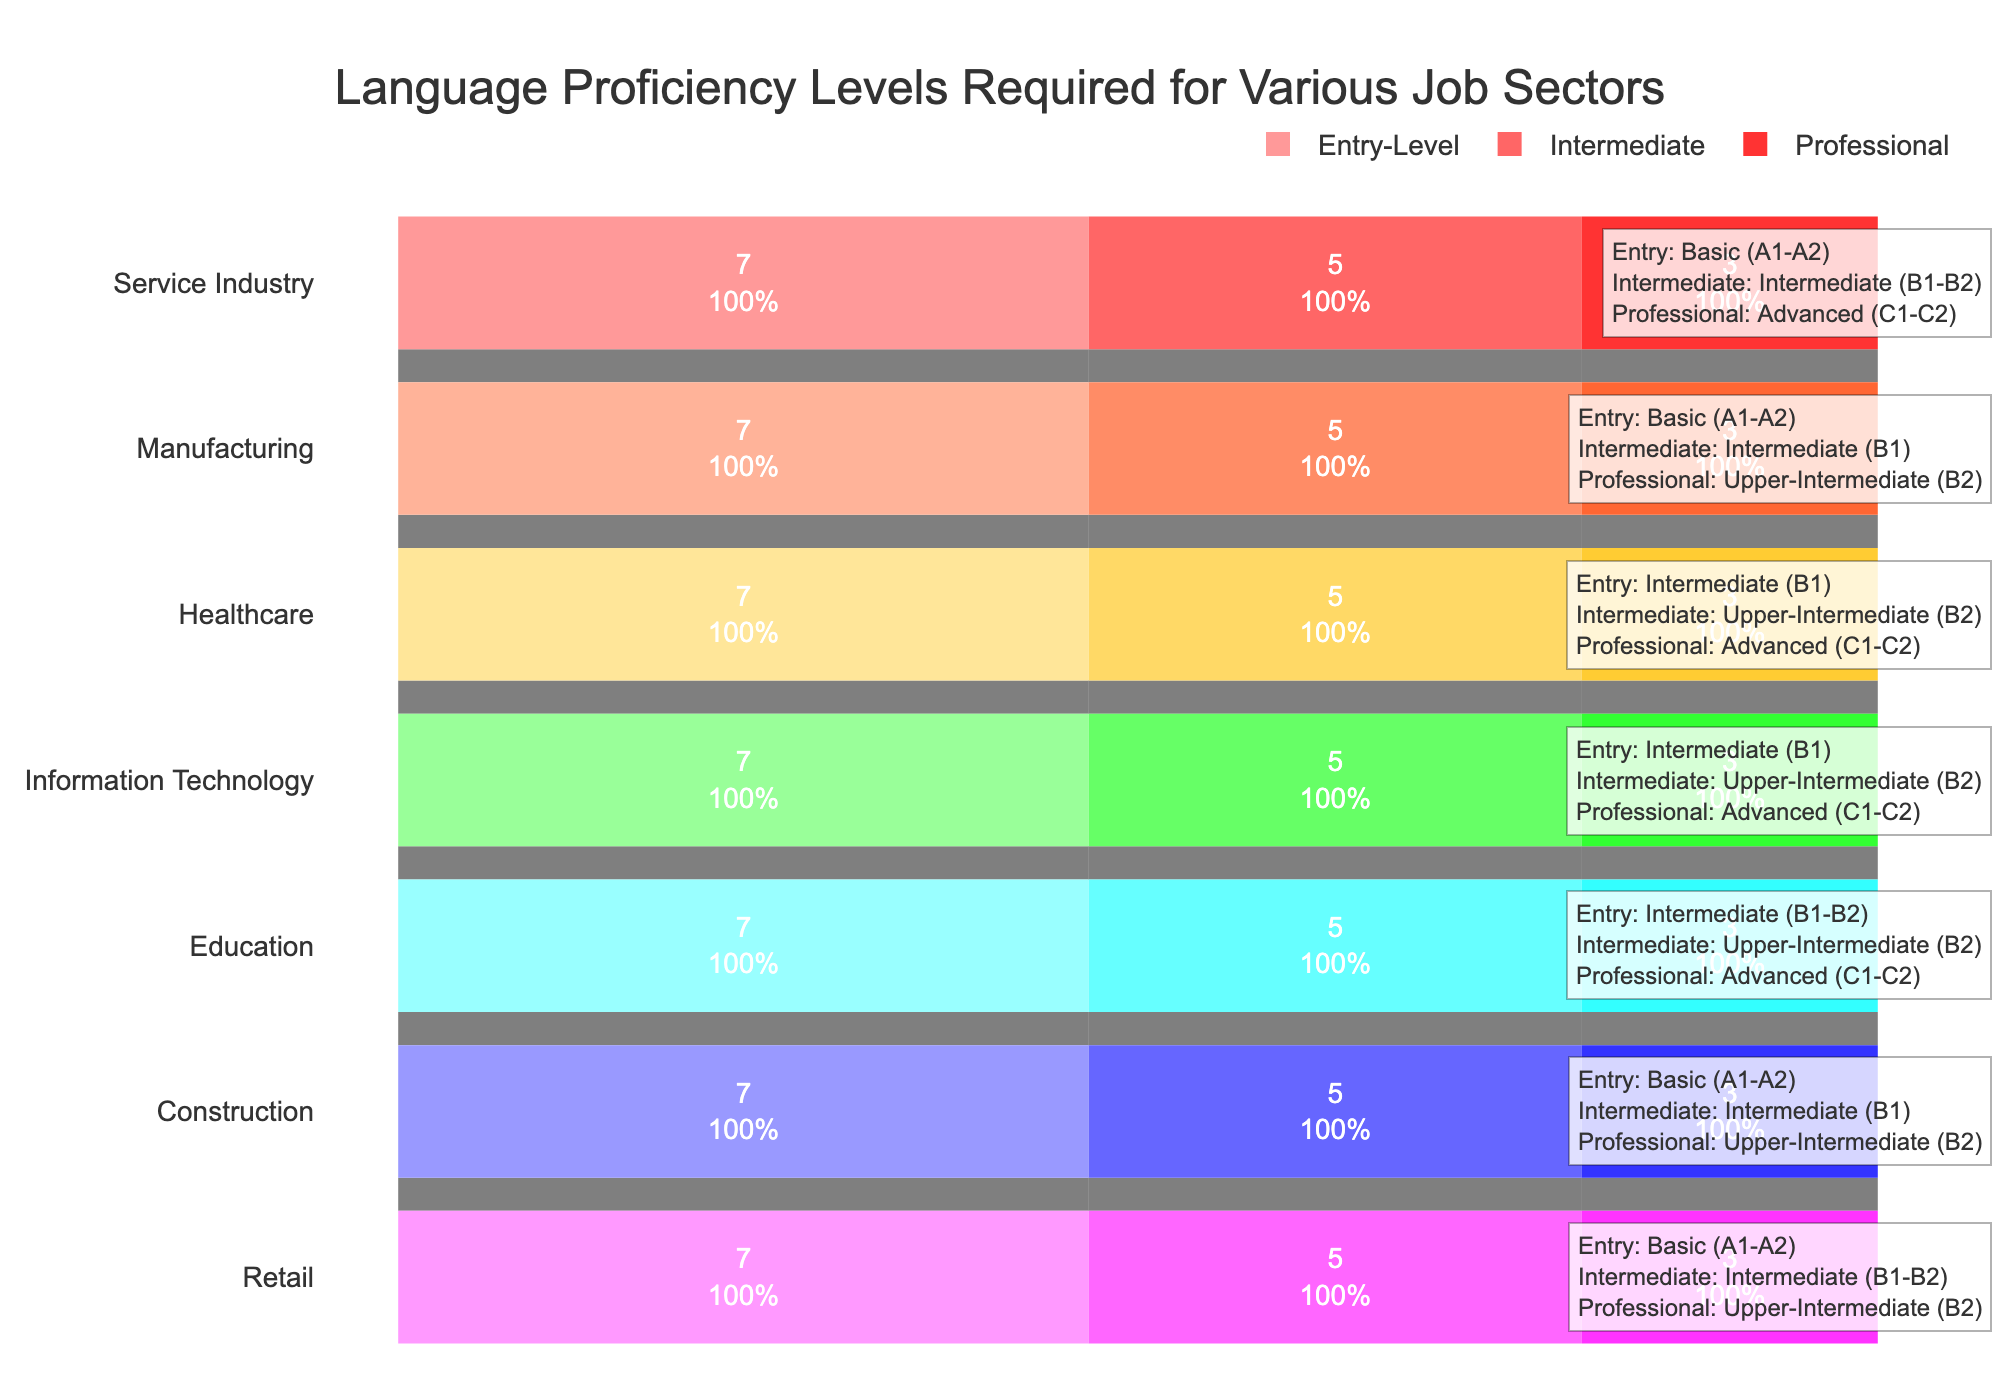What is the title of the funnel chart? The title is typically located at the top of the figure and is meant to give a succinct summary of the chart's purpose or content. In this case, the title directly states what the chart is depicting.
Answer: Language Proficiency Levels Required for Various Job Sectors Which job sector requires at least Intermediate (B1-B2) proficiency for entry-level roles? To answer, look for job sectors in the funnel chart that have "Intermediate" listed for the Entry-Level stage.
Answer: Education What language proficiency level is generally required for entry-level roles in the Service Industry? To answer, refer to the portion of the funnel chart that corresponds to the Service Industry and check the entry-level section.
Answer: Basic (A1-A2) How many job sectors are listed in the funnel chart? Count the number of unique job sectors listed on the y-axis of the funnel chart.
Answer: 7 Which job sectors require Advanced (C1-C2) proficiency for professional roles? Look at the professional proficiency segment (top-most part of each funnel) and identify those that specifically list Advanced (C1-C2) proficiency.
Answer: Service Industry, Healthcare, Information Technology, Education Compare the language proficiency required for intermediate roles in Retail and Healthcare. First, identify the language proficiency levels for intermediate roles in both Retail and Healthcare; then describe or compare the levels. Retail requires (B1-B2) while Healthcare requires (B2).
Answer: Retail: Intermediate (B1-B2), Healthcare: Upper-Intermediate (B2) What is the overall trend in language proficiency levels for job sectors as roles progress from entry-level to professional? Examine the progression of language requirements from entry-level to professional roles across all job sectors. There is a general requirement for higher proficiency levels as roles advance.
Answer: Increasing proficiency levels For the Construction sector, what is the progression of language proficiency from entry-level to professional roles? Follow the Construction sector's funnel: start at the entry-level stage, progress to the intermediate stage, and then to the professional stage.
Answer: Entry-Level: Basic (A1-A2), Intermediate: B1, Professional: B2 